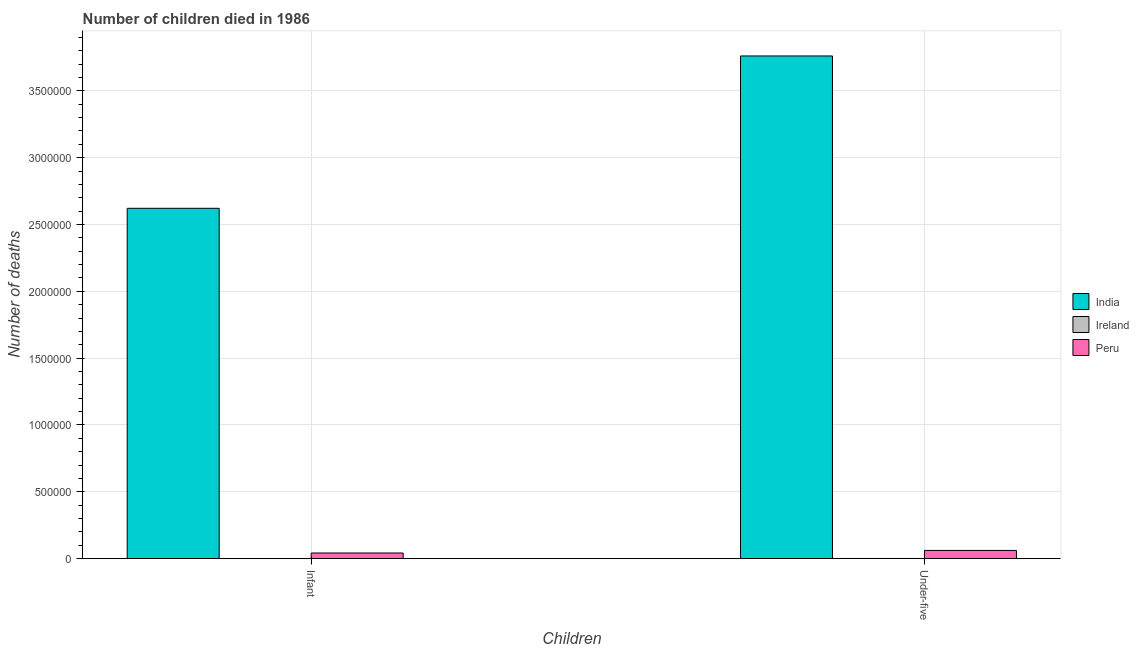How many different coloured bars are there?
Give a very brief answer. 3. Are the number of bars on each tick of the X-axis equal?
Offer a terse response. Yes. How many bars are there on the 1st tick from the left?
Give a very brief answer. 3. What is the label of the 2nd group of bars from the left?
Provide a short and direct response. Under-five. What is the number of infant deaths in Ireland?
Give a very brief answer. 554. Across all countries, what is the maximum number of infant deaths?
Ensure brevity in your answer.  2.62e+06. Across all countries, what is the minimum number of under-five deaths?
Keep it short and to the point. 670. In which country was the number of infant deaths maximum?
Your response must be concise. India. In which country was the number of under-five deaths minimum?
Offer a terse response. Ireland. What is the total number of infant deaths in the graph?
Ensure brevity in your answer.  2.66e+06. What is the difference between the number of infant deaths in Peru and that in Ireland?
Your answer should be compact. 4.10e+04. What is the difference between the number of under-five deaths in Peru and the number of infant deaths in India?
Provide a short and direct response. -2.56e+06. What is the average number of under-five deaths per country?
Your answer should be compact. 1.27e+06. What is the difference between the number of under-five deaths and number of infant deaths in Ireland?
Your answer should be compact. 116. In how many countries, is the number of infant deaths greater than 3600000 ?
Your answer should be compact. 0. What is the ratio of the number of under-five deaths in Ireland to that in India?
Offer a very short reply. 0. Is the number of under-five deaths in India less than that in Peru?
Your response must be concise. No. What does the 2nd bar from the left in Under-five represents?
Give a very brief answer. Ireland. Does the graph contain any zero values?
Provide a short and direct response. No. Where does the legend appear in the graph?
Keep it short and to the point. Center right. How many legend labels are there?
Ensure brevity in your answer.  3. How are the legend labels stacked?
Offer a terse response. Vertical. What is the title of the graph?
Ensure brevity in your answer.  Number of children died in 1986. What is the label or title of the X-axis?
Your response must be concise. Children. What is the label or title of the Y-axis?
Keep it short and to the point. Number of deaths. What is the Number of deaths of India in Infant?
Your answer should be very brief. 2.62e+06. What is the Number of deaths of Ireland in Infant?
Provide a succinct answer. 554. What is the Number of deaths of Peru in Infant?
Keep it short and to the point. 4.16e+04. What is the Number of deaths in India in Under-five?
Offer a terse response. 3.76e+06. What is the Number of deaths of Ireland in Under-five?
Provide a succinct answer. 670. What is the Number of deaths in Peru in Under-five?
Give a very brief answer. 6.09e+04. Across all Children, what is the maximum Number of deaths in India?
Ensure brevity in your answer.  3.76e+06. Across all Children, what is the maximum Number of deaths in Ireland?
Offer a terse response. 670. Across all Children, what is the maximum Number of deaths of Peru?
Your answer should be compact. 6.09e+04. Across all Children, what is the minimum Number of deaths of India?
Offer a terse response. 2.62e+06. Across all Children, what is the minimum Number of deaths of Ireland?
Keep it short and to the point. 554. Across all Children, what is the minimum Number of deaths in Peru?
Your answer should be compact. 4.16e+04. What is the total Number of deaths of India in the graph?
Provide a short and direct response. 6.38e+06. What is the total Number of deaths of Ireland in the graph?
Offer a terse response. 1224. What is the total Number of deaths of Peru in the graph?
Give a very brief answer. 1.02e+05. What is the difference between the Number of deaths of India in Infant and that in Under-five?
Ensure brevity in your answer.  -1.14e+06. What is the difference between the Number of deaths of Ireland in Infant and that in Under-five?
Ensure brevity in your answer.  -116. What is the difference between the Number of deaths of Peru in Infant and that in Under-five?
Provide a succinct answer. -1.93e+04. What is the difference between the Number of deaths of India in Infant and the Number of deaths of Ireland in Under-five?
Ensure brevity in your answer.  2.62e+06. What is the difference between the Number of deaths of India in Infant and the Number of deaths of Peru in Under-five?
Your answer should be very brief. 2.56e+06. What is the difference between the Number of deaths in Ireland in Infant and the Number of deaths in Peru in Under-five?
Make the answer very short. -6.04e+04. What is the average Number of deaths in India per Children?
Offer a very short reply. 3.19e+06. What is the average Number of deaths in Ireland per Children?
Keep it short and to the point. 612. What is the average Number of deaths in Peru per Children?
Provide a succinct answer. 5.12e+04. What is the difference between the Number of deaths of India and Number of deaths of Ireland in Infant?
Offer a very short reply. 2.62e+06. What is the difference between the Number of deaths in India and Number of deaths in Peru in Infant?
Your answer should be very brief. 2.58e+06. What is the difference between the Number of deaths of Ireland and Number of deaths of Peru in Infant?
Ensure brevity in your answer.  -4.10e+04. What is the difference between the Number of deaths in India and Number of deaths in Ireland in Under-five?
Offer a very short reply. 3.76e+06. What is the difference between the Number of deaths of India and Number of deaths of Peru in Under-five?
Offer a very short reply. 3.70e+06. What is the difference between the Number of deaths of Ireland and Number of deaths of Peru in Under-five?
Offer a terse response. -6.02e+04. What is the ratio of the Number of deaths in India in Infant to that in Under-five?
Provide a succinct answer. 0.7. What is the ratio of the Number of deaths in Ireland in Infant to that in Under-five?
Your answer should be compact. 0.83. What is the ratio of the Number of deaths in Peru in Infant to that in Under-five?
Provide a succinct answer. 0.68. What is the difference between the highest and the second highest Number of deaths of India?
Give a very brief answer. 1.14e+06. What is the difference between the highest and the second highest Number of deaths in Ireland?
Your answer should be compact. 116. What is the difference between the highest and the second highest Number of deaths in Peru?
Offer a very short reply. 1.93e+04. What is the difference between the highest and the lowest Number of deaths of India?
Your answer should be very brief. 1.14e+06. What is the difference between the highest and the lowest Number of deaths in Ireland?
Offer a very short reply. 116. What is the difference between the highest and the lowest Number of deaths in Peru?
Keep it short and to the point. 1.93e+04. 